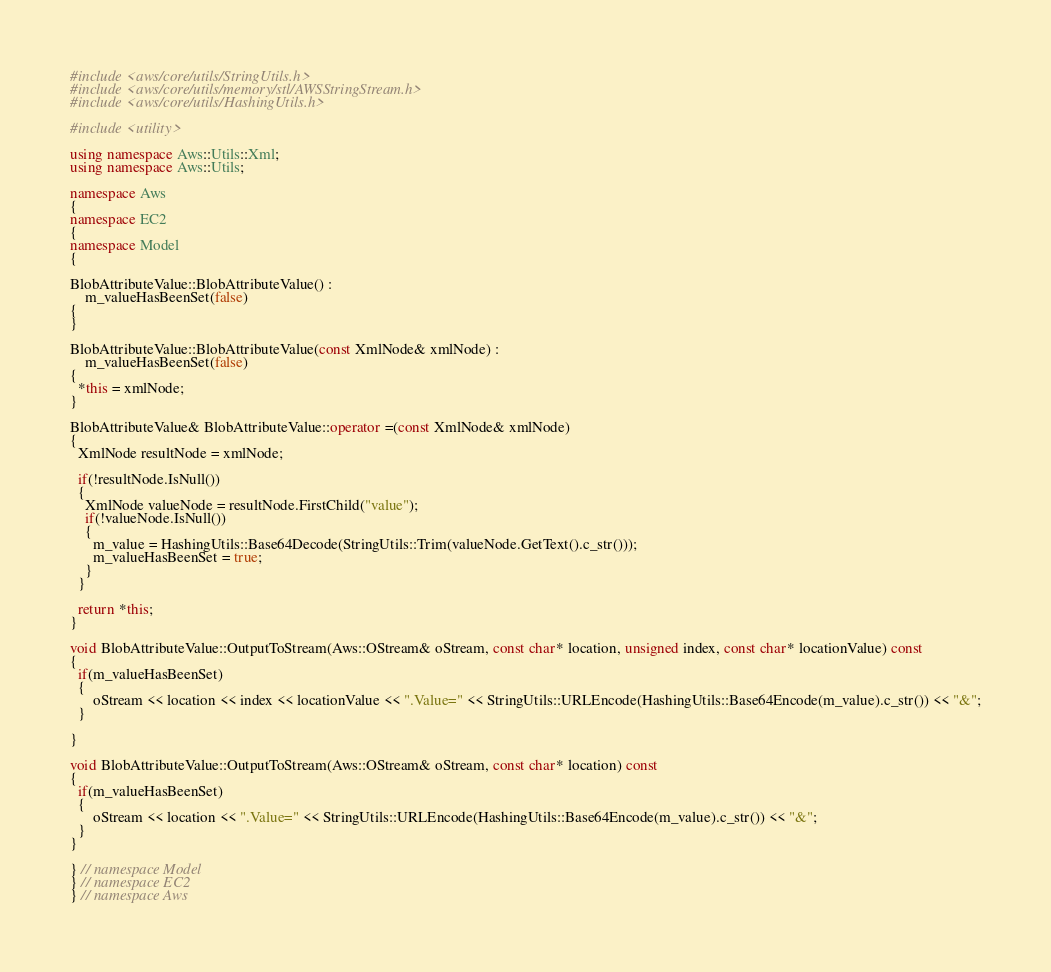<code> <loc_0><loc_0><loc_500><loc_500><_C++_>#include <aws/core/utils/StringUtils.h>
#include <aws/core/utils/memory/stl/AWSStringStream.h>
#include <aws/core/utils/HashingUtils.h>

#include <utility>

using namespace Aws::Utils::Xml;
using namespace Aws::Utils;

namespace Aws
{
namespace EC2
{
namespace Model
{

BlobAttributeValue::BlobAttributeValue() : 
    m_valueHasBeenSet(false)
{
}

BlobAttributeValue::BlobAttributeValue(const XmlNode& xmlNode) : 
    m_valueHasBeenSet(false)
{
  *this = xmlNode;
}

BlobAttributeValue& BlobAttributeValue::operator =(const XmlNode& xmlNode)
{
  XmlNode resultNode = xmlNode;

  if(!resultNode.IsNull())
  {
    XmlNode valueNode = resultNode.FirstChild("value");
    if(!valueNode.IsNull())
    {
      m_value = HashingUtils::Base64Decode(StringUtils::Trim(valueNode.GetText().c_str()));
      m_valueHasBeenSet = true;
    }
  }

  return *this;
}

void BlobAttributeValue::OutputToStream(Aws::OStream& oStream, const char* location, unsigned index, const char* locationValue) const
{
  if(m_valueHasBeenSet)
  {
      oStream << location << index << locationValue << ".Value=" << StringUtils::URLEncode(HashingUtils::Base64Encode(m_value).c_str()) << "&";
  }

}

void BlobAttributeValue::OutputToStream(Aws::OStream& oStream, const char* location) const
{
  if(m_valueHasBeenSet)
  {
      oStream << location << ".Value=" << StringUtils::URLEncode(HashingUtils::Base64Encode(m_value).c_str()) << "&";
  }
}

} // namespace Model
} // namespace EC2
} // namespace Aws
</code> 